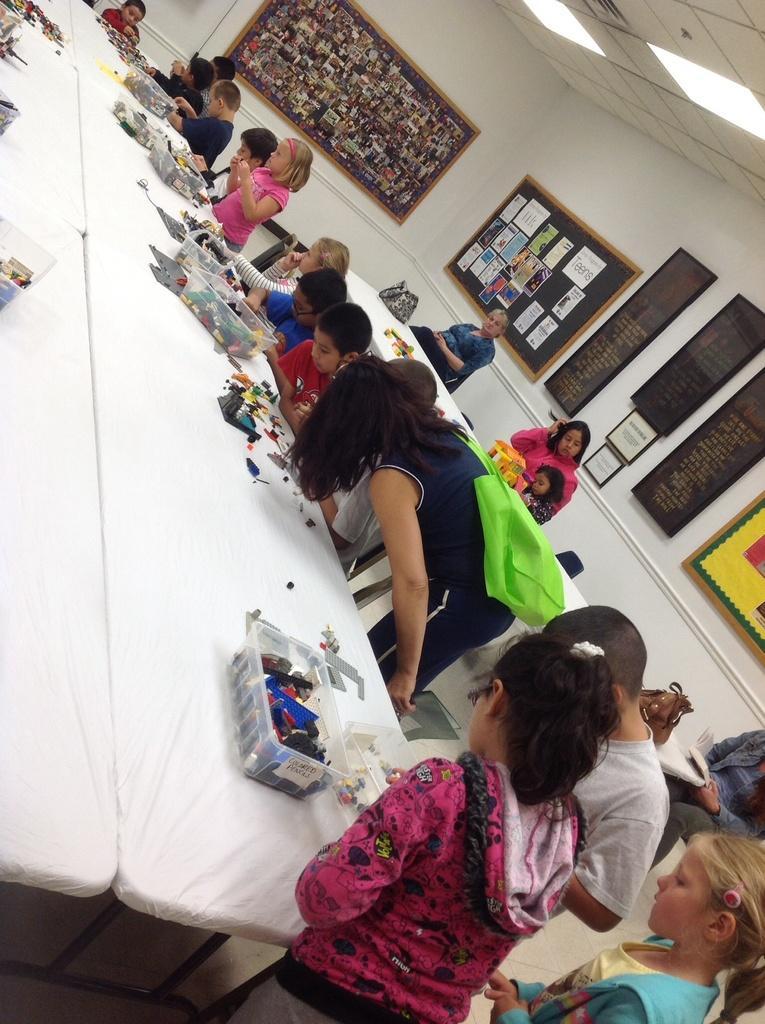Could you give a brief overview of what you see in this image? In this image we can see there are few kids standing and few are sitting. And there are a few people standing and few are sitting on the chair. In front of them there is a table, on the table there is a bag and box, in the box there are few objects. At the back there are boards and posters attached to the wall. At the top there is a ceiling with lights. 